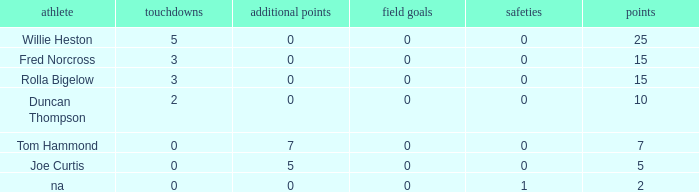Which Points is the lowest one that has Touchdowns smaller than 2, and an Extra points of 7, and a Field goals smaller than 0? None. 